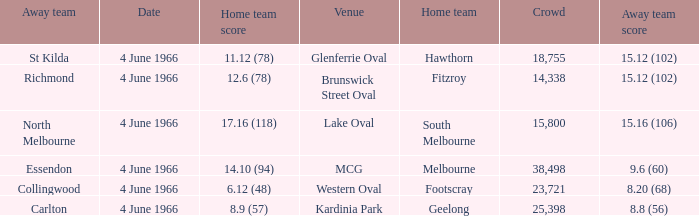What is the score of the away team that played home team Geelong? 8.8 (56). 